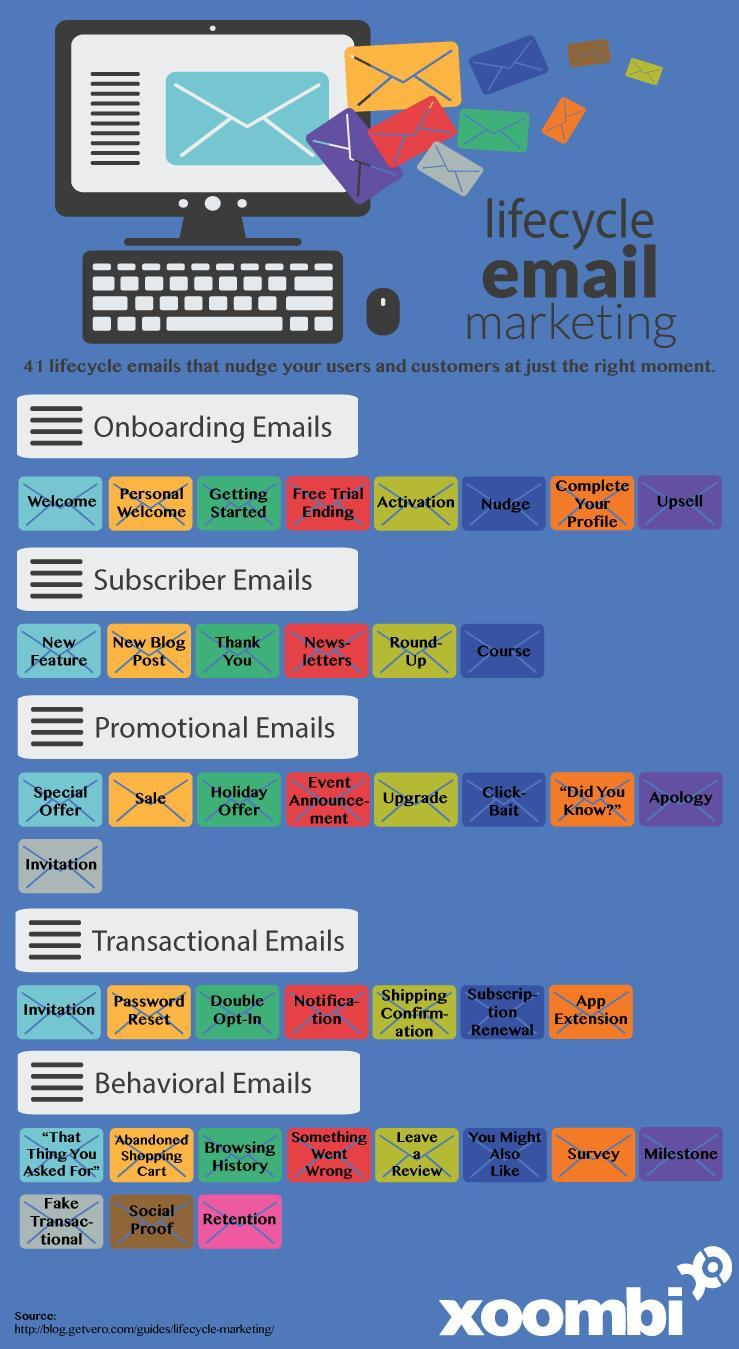Special offer emails belong to which category?
Answer the question with a short phrase. Promotional emails Both 'Welcome' and 'Getting started' emails fall under which category? Onboarding emails Invitation emails belong to two categories. Which are they? Promotional emails, Transactional emails Under which category does notification emails fall? Transactional emails Under which category do activation emails come? Onboarding emails Under which category of emails is the highest number of lifecycle emails ? Behavioural emails Into how many types are the lifecycle emails categorised? 5 How many envelopes are shown under onboarding emails? 8 